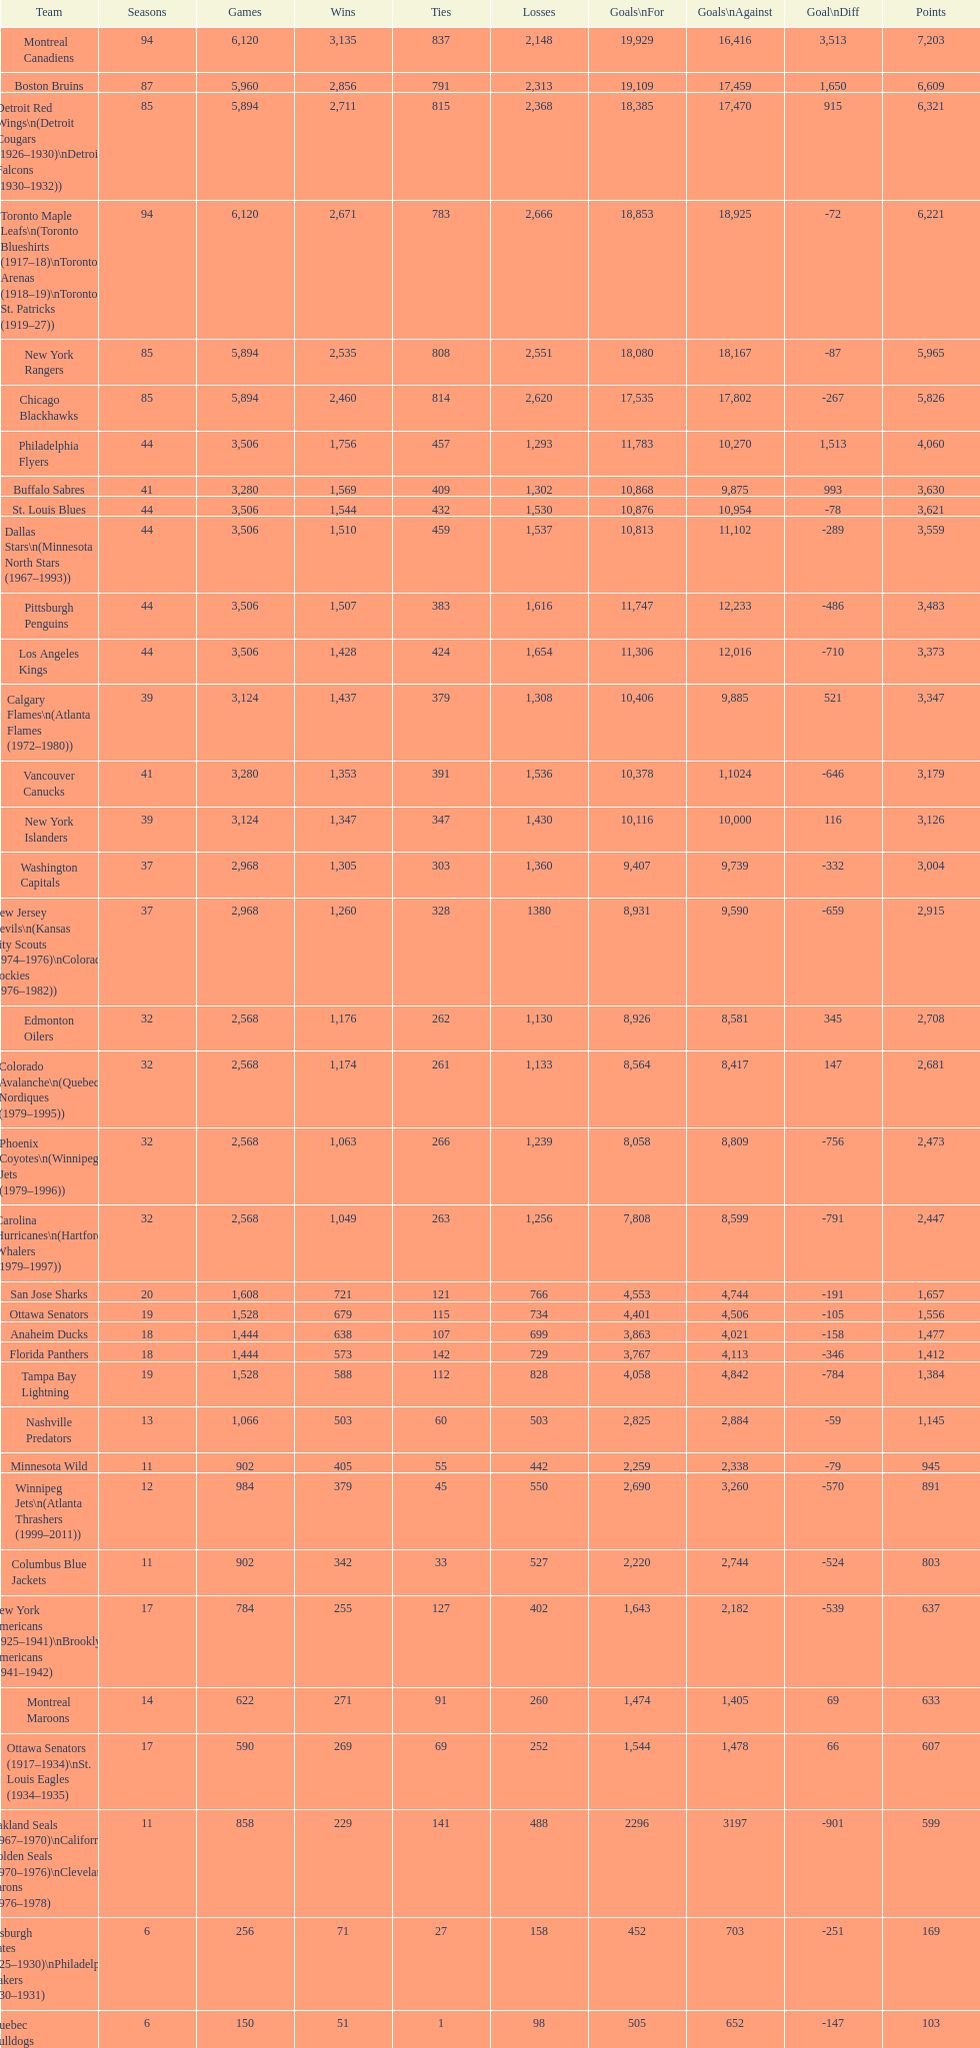I'm looking to parse the entire table for insights. Could you assist me with that? {'header': ['Team', 'Seasons', 'Games', 'Wins', 'Ties', 'Losses', 'Goals\\nFor', 'Goals\\nAgainst', 'Goal\\nDiff', 'Points'], 'rows': [['Montreal Canadiens', '94', '6,120', '3,135', '837', '2,148', '19,929', '16,416', '3,513', '7,203'], ['Boston Bruins', '87', '5,960', '2,856', '791', '2,313', '19,109', '17,459', '1,650', '6,609'], ['Detroit Red Wings\\n(Detroit Cougars (1926–1930)\\nDetroit Falcons (1930–1932))', '85', '5,894', '2,711', '815', '2,368', '18,385', '17,470', '915', '6,321'], ['Toronto Maple Leafs\\n(Toronto Blueshirts (1917–18)\\nToronto Arenas (1918–19)\\nToronto St. Patricks (1919–27))', '94', '6,120', '2,671', '783', '2,666', '18,853', '18,925', '-72', '6,221'], ['New York Rangers', '85', '5,894', '2,535', '808', '2,551', '18,080', '18,167', '-87', '5,965'], ['Chicago Blackhawks', '85', '5,894', '2,460', '814', '2,620', '17,535', '17,802', '-267', '5,826'], ['Philadelphia Flyers', '44', '3,506', '1,756', '457', '1,293', '11,783', '10,270', '1,513', '4,060'], ['Buffalo Sabres', '41', '3,280', '1,569', '409', '1,302', '10,868', '9,875', '993', '3,630'], ['St. Louis Blues', '44', '3,506', '1,544', '432', '1,530', '10,876', '10,954', '-78', '3,621'], ['Dallas Stars\\n(Minnesota North Stars (1967–1993))', '44', '3,506', '1,510', '459', '1,537', '10,813', '11,102', '-289', '3,559'], ['Pittsburgh Penguins', '44', '3,506', '1,507', '383', '1,616', '11,747', '12,233', '-486', '3,483'], ['Los Angeles Kings', '44', '3,506', '1,428', '424', '1,654', '11,306', '12,016', '-710', '3,373'], ['Calgary Flames\\n(Atlanta Flames (1972–1980))', '39', '3,124', '1,437', '379', '1,308', '10,406', '9,885', '521', '3,347'], ['Vancouver Canucks', '41', '3,280', '1,353', '391', '1,536', '10,378', '1,1024', '-646', '3,179'], ['New York Islanders', '39', '3,124', '1,347', '347', '1,430', '10,116', '10,000', '116', '3,126'], ['Washington Capitals', '37', '2,968', '1,305', '303', '1,360', '9,407', '9,739', '-332', '3,004'], ['New Jersey Devils\\n(Kansas City Scouts (1974–1976)\\nColorado Rockies (1976–1982))', '37', '2,968', '1,260', '328', '1380', '8,931', '9,590', '-659', '2,915'], ['Edmonton Oilers', '32', '2,568', '1,176', '262', '1,130', '8,926', '8,581', '345', '2,708'], ['Colorado Avalanche\\n(Quebec Nordiques (1979–1995))', '32', '2,568', '1,174', '261', '1,133', '8,564', '8,417', '147', '2,681'], ['Phoenix Coyotes\\n(Winnipeg Jets (1979–1996))', '32', '2,568', '1,063', '266', '1,239', '8,058', '8,809', '-756', '2,473'], ['Carolina Hurricanes\\n(Hartford Whalers (1979–1997))', '32', '2,568', '1,049', '263', '1,256', '7,808', '8,599', '-791', '2,447'], ['San Jose Sharks', '20', '1,608', '721', '121', '766', '4,553', '4,744', '-191', '1,657'], ['Ottawa Senators', '19', '1,528', '679', '115', '734', '4,401', '4,506', '-105', '1,556'], ['Anaheim Ducks', '18', '1,444', '638', '107', '699', '3,863', '4,021', '-158', '1,477'], ['Florida Panthers', '18', '1,444', '573', '142', '729', '3,767', '4,113', '-346', '1,412'], ['Tampa Bay Lightning', '19', '1,528', '588', '112', '828', '4,058', '4,842', '-784', '1,384'], ['Nashville Predators', '13', '1,066', '503', '60', '503', '2,825', '2,884', '-59', '1,145'], ['Minnesota Wild', '11', '902', '405', '55', '442', '2,259', '2,338', '-79', '945'], ['Winnipeg Jets\\n(Atlanta Thrashers (1999–2011))', '12', '984', '379', '45', '550', '2,690', '3,260', '-570', '891'], ['Columbus Blue Jackets', '11', '902', '342', '33', '527', '2,220', '2,744', '-524', '803'], ['New York Americans (1925–1941)\\nBrooklyn Americans (1941–1942)', '17', '784', '255', '127', '402', '1,643', '2,182', '-539', '637'], ['Montreal Maroons', '14', '622', '271', '91', '260', '1,474', '1,405', '69', '633'], ['Ottawa Senators (1917–1934)\\nSt. Louis Eagles (1934–1935)', '17', '590', '269', '69', '252', '1,544', '1,478', '66', '607'], ['Oakland Seals (1967–1970)\\nCalifornia Golden Seals (1970–1976)\\nCleveland Barons (1976–1978)', '11', '858', '229', '141', '488', '2296', '3197', '-901', '599'], ['Pittsburgh Pirates (1925–1930)\\nPhiladelphia Quakers (1930–1931)', '6', '256', '71', '27', '158', '452', '703', '-251', '169'], ['Quebec Bulldogs (1919–1920)\\nHamilton Tigers (1920–1925)', '6', '150', '51', '1', '98', '505', '652', '-147', '103'], ['Montreal Wanderers', '1', '6', '1', '0', '5', '17', '35', '-18', '2']]} What is the overall score of the los angeles kings? 3,373. 